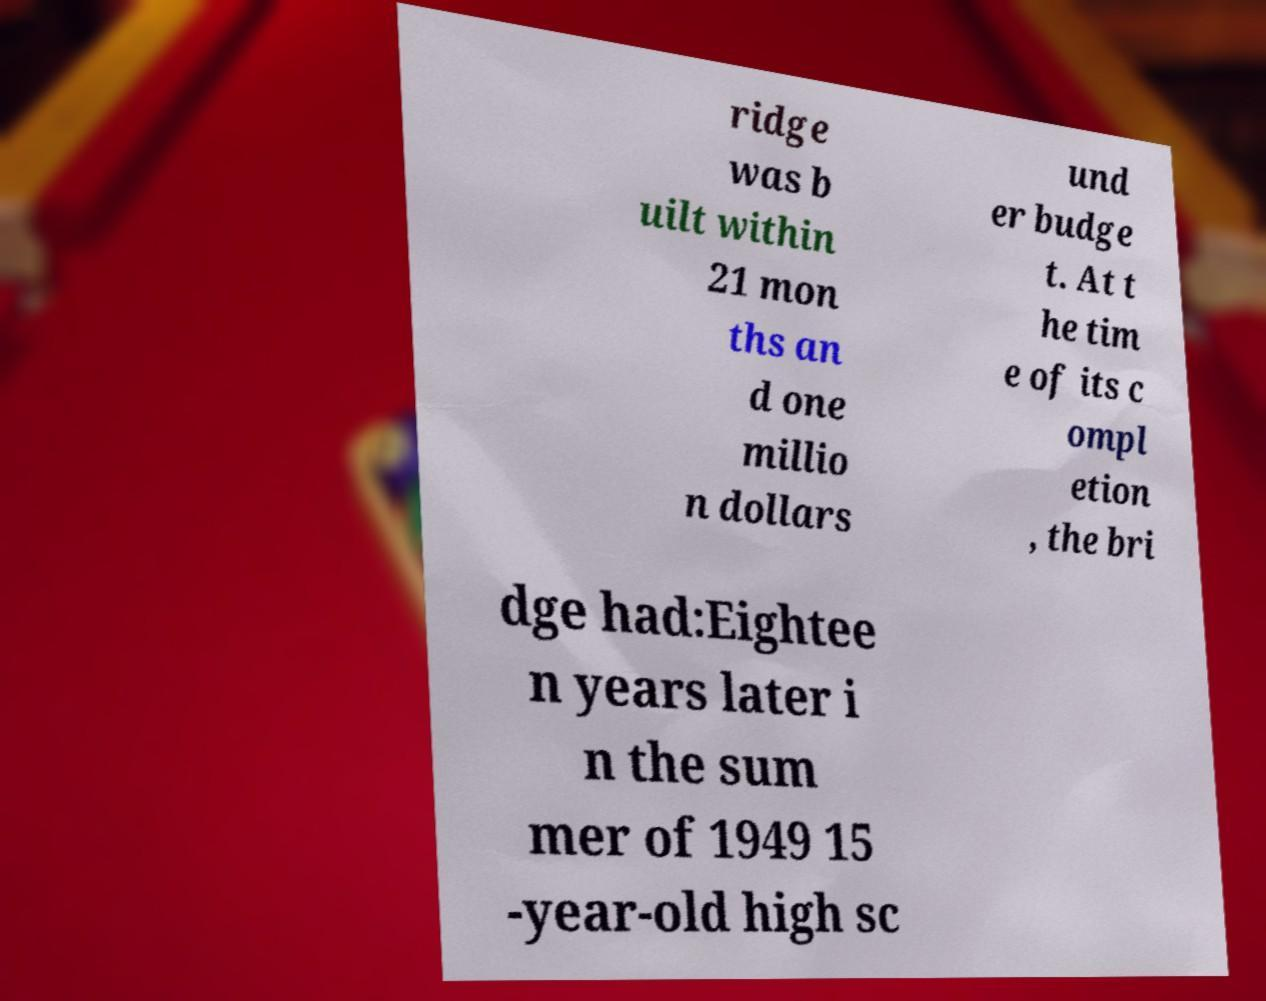What messages or text are displayed in this image? I need them in a readable, typed format. ridge was b uilt within 21 mon ths an d one millio n dollars und er budge t. At t he tim e of its c ompl etion , the bri dge had:Eightee n years later i n the sum mer of 1949 15 -year-old high sc 